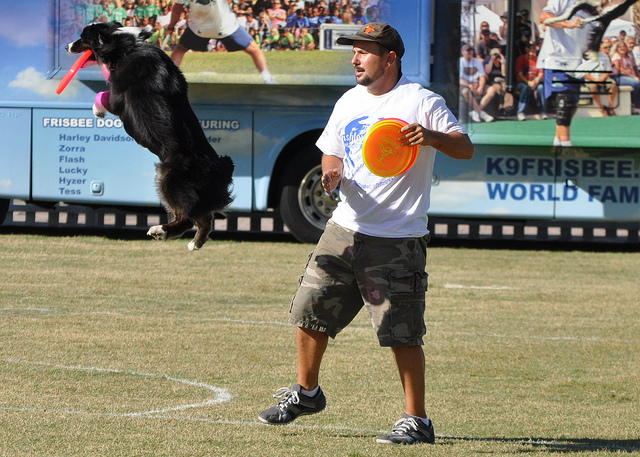Describe the action taking place in this image. In this image, a man throws a Frisbee while a dog, mid-leap, reaches out to catch it. The scene likely represents a moment from a Frisbee dog competition, highlighting the agility and training of the dog. 